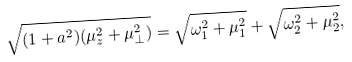Convert formula to latex. <formula><loc_0><loc_0><loc_500><loc_500>\sqrt { ( 1 + a ^ { 2 } ) ( \mu ^ { 2 } _ { z } + \mu ^ { 2 } _ { \bot } ) } = \sqrt { \omega ^ { 2 } _ { 1 } + \mu ^ { 2 } _ { 1 } } + \sqrt { \omega ^ { 2 } _ { 2 } + \mu ^ { 2 } _ { 2 } } ,</formula> 